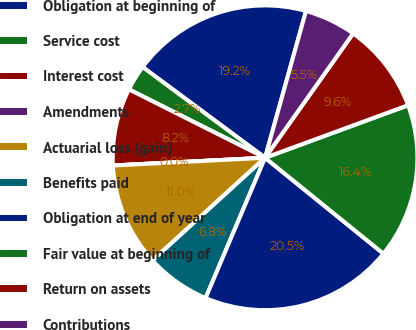Convert chart. <chart><loc_0><loc_0><loc_500><loc_500><pie_chart><fcel>Obligation at beginning of<fcel>Service cost<fcel>Interest cost<fcel>Amendments<fcel>Actuarial loss (gain)<fcel>Benefits paid<fcel>Obligation at end of year<fcel>Fair value at beginning of<fcel>Return on assets<fcel>Contributions<nl><fcel>19.18%<fcel>2.74%<fcel>8.22%<fcel>0.0%<fcel>10.96%<fcel>6.85%<fcel>20.55%<fcel>16.44%<fcel>9.59%<fcel>5.48%<nl></chart> 